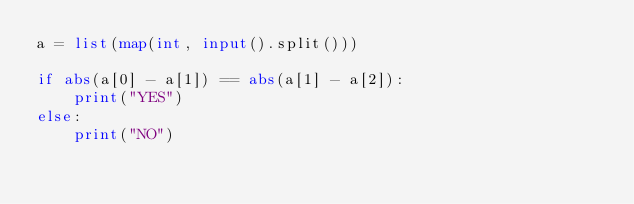Convert code to text. <code><loc_0><loc_0><loc_500><loc_500><_Python_>a = list(map(int, input().split()))

if abs(a[0] - a[1]) == abs(a[1] - a[2]):
    print("YES")
else:
    print("NO")</code> 